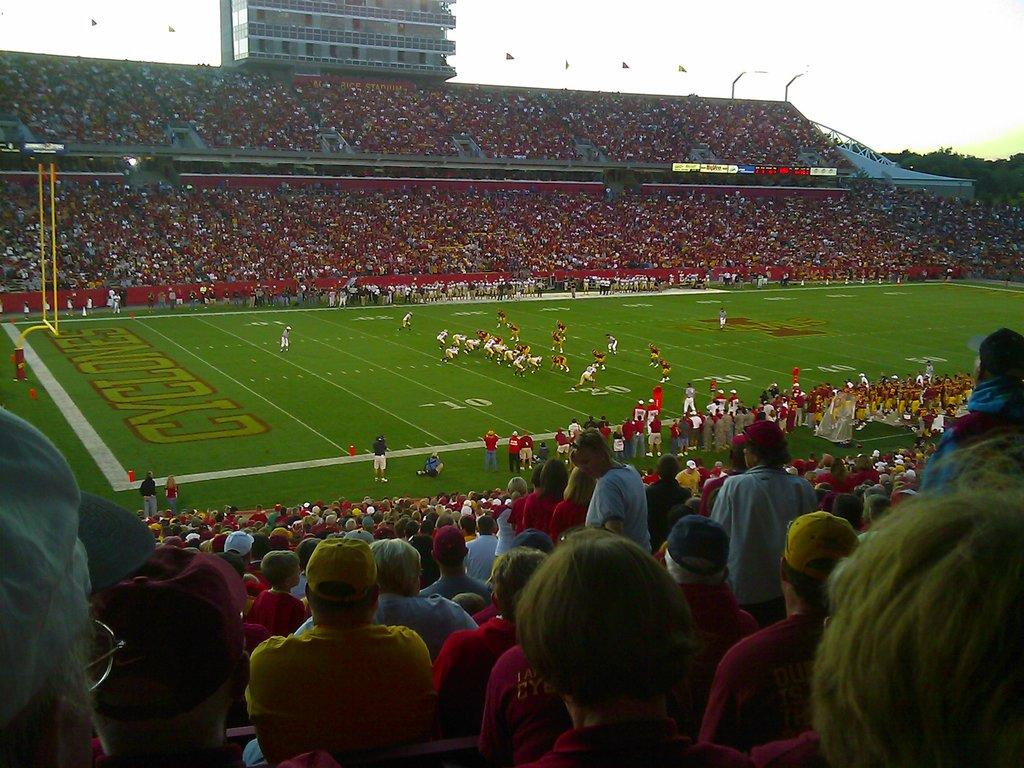What is the setting of the image? The setting of the image is a greenery ground where persons are standing. Who else is present in the image besides the standing persons? There are audience members on either side of the standing persons. What can be seen in the background of the image? In the background, there is a building, flags, and trees. What type of pan is being used by the persons in the image? There is no pan visible in the image; the persons are standing on a greenery ground. What time of day is depicted in the image? The time of day is not specified in the image, so it cannot be determined. 